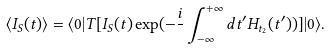<formula> <loc_0><loc_0><loc_500><loc_500>\langle I _ { S } ( t ) \rangle = \langle 0 | T [ I _ { S } ( t ) \exp ( - \frac { i } { } \int _ { - \infty } ^ { + \infty } d t ^ { \prime } H _ { t _ { 2 } } ( t ^ { \prime } ) ) ] | 0 \rangle .</formula> 